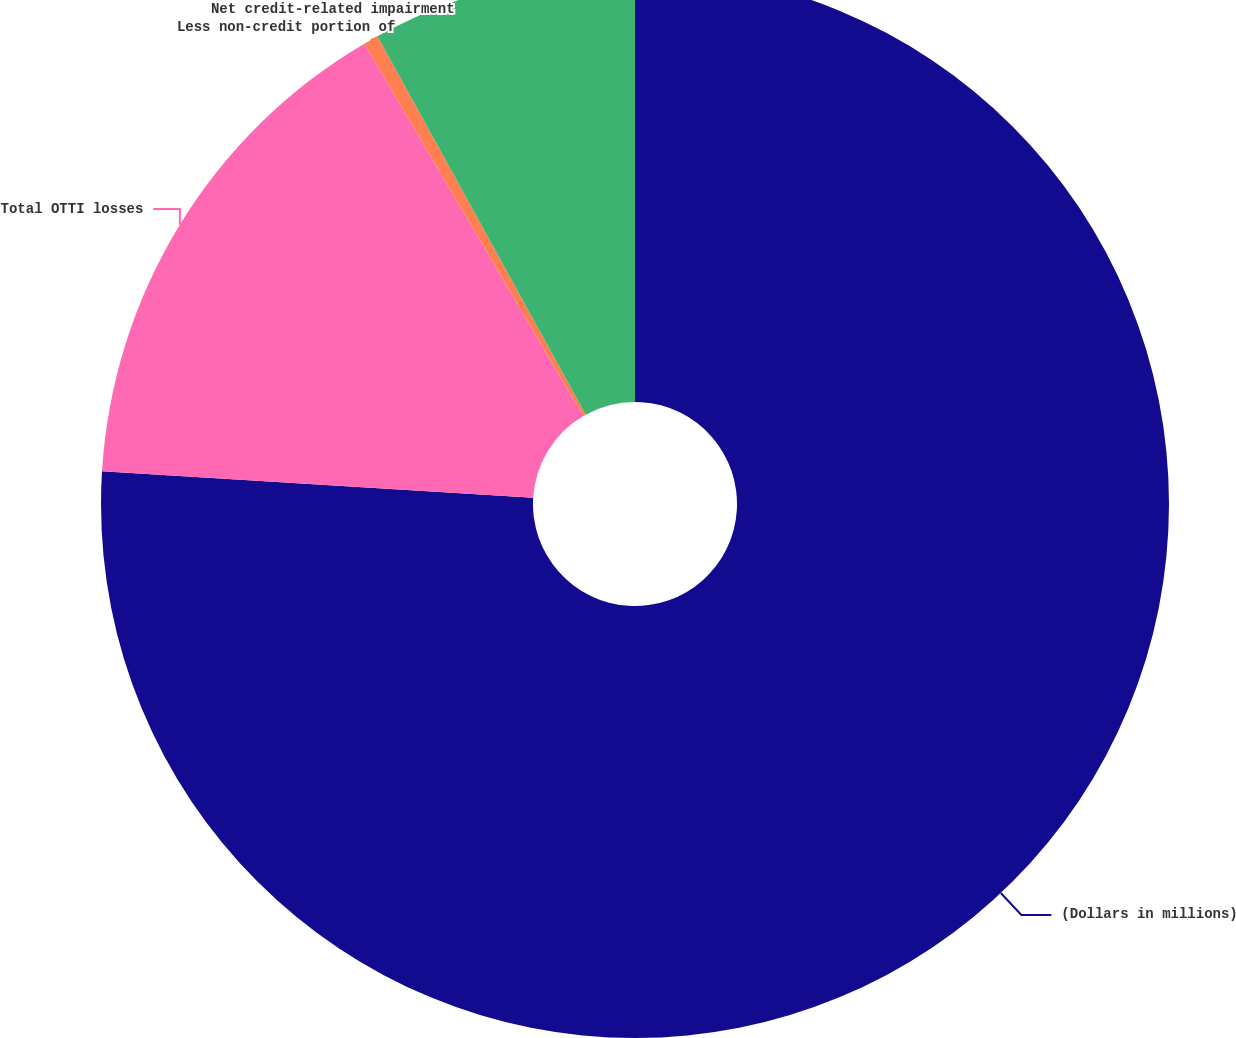Convert chart to OTSL. <chart><loc_0><loc_0><loc_500><loc_500><pie_chart><fcel>(Dollars in millions)<fcel>Total OTTI losses<fcel>Less non-credit portion of<fcel>Net credit-related impairment<nl><fcel>75.98%<fcel>15.56%<fcel>0.45%<fcel>8.01%<nl></chart> 